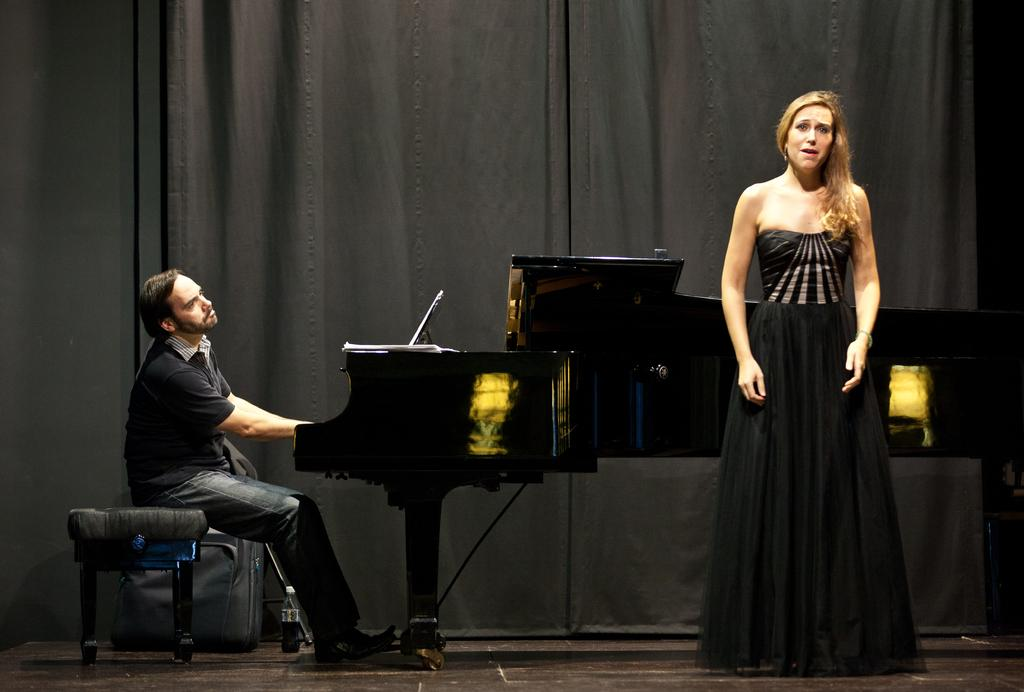What is the man in the image doing? The man is sitting on a stool and playing a keyboard. What is the position of the woman in the image? The woman is standing. What can be seen in the background of the image? There is a black curtain in the background of the image. What type of steel is used to construct the keyboard in the image? There is no information about the material used to construct the keyboard in the image. 